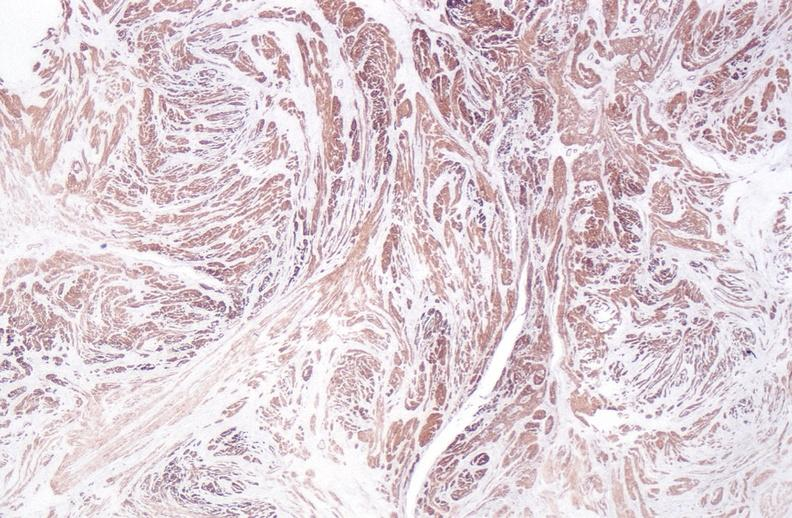what does this image show?
Answer the question using a single word or phrase. Leiomyoma 